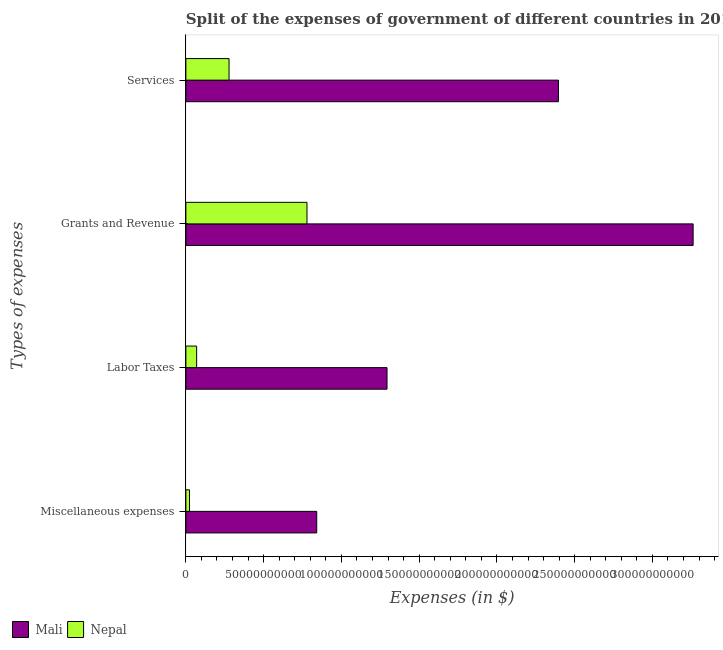How many different coloured bars are there?
Keep it short and to the point. 2. Are the number of bars per tick equal to the number of legend labels?
Offer a terse response. Yes. How many bars are there on the 1st tick from the bottom?
Your answer should be compact. 2. What is the label of the 4th group of bars from the top?
Offer a terse response. Miscellaneous expenses. What is the amount spent on grants and revenue in Nepal?
Your response must be concise. 7.79e+1. Across all countries, what is the maximum amount spent on grants and revenue?
Your answer should be compact. 3.26e+11. Across all countries, what is the minimum amount spent on miscellaneous expenses?
Provide a short and direct response. 2.33e+09. In which country was the amount spent on miscellaneous expenses maximum?
Keep it short and to the point. Mali. In which country was the amount spent on labor taxes minimum?
Keep it short and to the point. Nepal. What is the total amount spent on labor taxes in the graph?
Keep it short and to the point. 1.36e+11. What is the difference between the amount spent on grants and revenue in Nepal and that in Mali?
Offer a terse response. -2.48e+11. What is the difference between the amount spent on grants and revenue in Mali and the amount spent on services in Nepal?
Provide a short and direct response. 2.98e+11. What is the average amount spent on labor taxes per country?
Your answer should be very brief. 6.81e+1. What is the difference between the amount spent on grants and revenue and amount spent on miscellaneous expenses in Nepal?
Keep it short and to the point. 7.55e+1. In how many countries, is the amount spent on labor taxes greater than 150000000000 $?
Make the answer very short. 0. What is the ratio of the amount spent on services in Nepal to that in Mali?
Make the answer very short. 0.12. Is the amount spent on labor taxes in Mali less than that in Nepal?
Your response must be concise. No. Is the difference between the amount spent on grants and revenue in Nepal and Mali greater than the difference between the amount spent on services in Nepal and Mali?
Keep it short and to the point. No. What is the difference between the highest and the second highest amount spent on grants and revenue?
Make the answer very short. 2.48e+11. What is the difference between the highest and the lowest amount spent on services?
Your answer should be very brief. 2.12e+11. In how many countries, is the amount spent on grants and revenue greater than the average amount spent on grants and revenue taken over all countries?
Provide a short and direct response. 1. Is the sum of the amount spent on labor taxes in Nepal and Mali greater than the maximum amount spent on miscellaneous expenses across all countries?
Keep it short and to the point. Yes. Is it the case that in every country, the sum of the amount spent on labor taxes and amount spent on miscellaneous expenses is greater than the sum of amount spent on grants and revenue and amount spent on services?
Keep it short and to the point. No. What does the 2nd bar from the top in Grants and Revenue represents?
Provide a short and direct response. Mali. What does the 1st bar from the bottom in Miscellaneous expenses represents?
Keep it short and to the point. Mali. Is it the case that in every country, the sum of the amount spent on miscellaneous expenses and amount spent on labor taxes is greater than the amount spent on grants and revenue?
Offer a very short reply. No. How many countries are there in the graph?
Ensure brevity in your answer.  2. What is the difference between two consecutive major ticks on the X-axis?
Keep it short and to the point. 5.00e+1. Are the values on the major ticks of X-axis written in scientific E-notation?
Provide a succinct answer. No. Does the graph contain any zero values?
Ensure brevity in your answer.  No. Where does the legend appear in the graph?
Give a very brief answer. Bottom left. What is the title of the graph?
Your answer should be very brief. Split of the expenses of government of different countries in 2013. Does "Chile" appear as one of the legend labels in the graph?
Offer a very short reply. No. What is the label or title of the X-axis?
Your answer should be compact. Expenses (in $). What is the label or title of the Y-axis?
Provide a succinct answer. Types of expenses. What is the Expenses (in $) in Mali in Miscellaneous expenses?
Make the answer very short. 8.41e+1. What is the Expenses (in $) in Nepal in Miscellaneous expenses?
Provide a succinct answer. 2.33e+09. What is the Expenses (in $) of Mali in Labor Taxes?
Keep it short and to the point. 1.29e+11. What is the Expenses (in $) of Nepal in Labor Taxes?
Offer a very short reply. 6.92e+09. What is the Expenses (in $) of Mali in Grants and Revenue?
Make the answer very short. 3.26e+11. What is the Expenses (in $) of Nepal in Grants and Revenue?
Your response must be concise. 7.79e+1. What is the Expenses (in $) of Mali in Services?
Give a very brief answer. 2.40e+11. What is the Expenses (in $) of Nepal in Services?
Make the answer very short. 2.78e+1. Across all Types of expenses, what is the maximum Expenses (in $) in Mali?
Give a very brief answer. 3.26e+11. Across all Types of expenses, what is the maximum Expenses (in $) of Nepal?
Offer a terse response. 7.79e+1. Across all Types of expenses, what is the minimum Expenses (in $) in Mali?
Provide a succinct answer. 8.41e+1. Across all Types of expenses, what is the minimum Expenses (in $) in Nepal?
Your answer should be compact. 2.33e+09. What is the total Expenses (in $) of Mali in the graph?
Provide a succinct answer. 7.79e+11. What is the total Expenses (in $) in Nepal in the graph?
Give a very brief answer. 1.15e+11. What is the difference between the Expenses (in $) of Mali in Miscellaneous expenses and that in Labor Taxes?
Make the answer very short. -4.52e+1. What is the difference between the Expenses (in $) in Nepal in Miscellaneous expenses and that in Labor Taxes?
Provide a short and direct response. -4.59e+09. What is the difference between the Expenses (in $) of Mali in Miscellaneous expenses and that in Grants and Revenue?
Your response must be concise. -2.42e+11. What is the difference between the Expenses (in $) of Nepal in Miscellaneous expenses and that in Grants and Revenue?
Provide a short and direct response. -7.55e+1. What is the difference between the Expenses (in $) of Mali in Miscellaneous expenses and that in Services?
Provide a succinct answer. -1.55e+11. What is the difference between the Expenses (in $) in Nepal in Miscellaneous expenses and that in Services?
Offer a terse response. -2.54e+1. What is the difference between the Expenses (in $) in Mali in Labor Taxes and that in Grants and Revenue?
Offer a terse response. -1.97e+11. What is the difference between the Expenses (in $) in Nepal in Labor Taxes and that in Grants and Revenue?
Ensure brevity in your answer.  -7.10e+1. What is the difference between the Expenses (in $) of Mali in Labor Taxes and that in Services?
Give a very brief answer. -1.10e+11. What is the difference between the Expenses (in $) in Nepal in Labor Taxes and that in Services?
Provide a short and direct response. -2.08e+1. What is the difference between the Expenses (in $) of Mali in Grants and Revenue and that in Services?
Your response must be concise. 8.66e+1. What is the difference between the Expenses (in $) in Nepal in Grants and Revenue and that in Services?
Offer a terse response. 5.01e+1. What is the difference between the Expenses (in $) of Mali in Miscellaneous expenses and the Expenses (in $) of Nepal in Labor Taxes?
Offer a terse response. 7.72e+1. What is the difference between the Expenses (in $) in Mali in Miscellaneous expenses and the Expenses (in $) in Nepal in Grants and Revenue?
Give a very brief answer. 6.26e+09. What is the difference between the Expenses (in $) in Mali in Miscellaneous expenses and the Expenses (in $) in Nepal in Services?
Give a very brief answer. 5.64e+1. What is the difference between the Expenses (in $) in Mali in Labor Taxes and the Expenses (in $) in Nepal in Grants and Revenue?
Your answer should be very brief. 5.15e+1. What is the difference between the Expenses (in $) in Mali in Labor Taxes and the Expenses (in $) in Nepal in Services?
Ensure brevity in your answer.  1.02e+11. What is the difference between the Expenses (in $) of Mali in Grants and Revenue and the Expenses (in $) of Nepal in Services?
Your response must be concise. 2.98e+11. What is the average Expenses (in $) in Mali per Types of expenses?
Give a very brief answer. 1.95e+11. What is the average Expenses (in $) in Nepal per Types of expenses?
Give a very brief answer. 2.87e+1. What is the difference between the Expenses (in $) in Mali and Expenses (in $) in Nepal in Miscellaneous expenses?
Ensure brevity in your answer.  8.18e+1. What is the difference between the Expenses (in $) of Mali and Expenses (in $) of Nepal in Labor Taxes?
Offer a terse response. 1.22e+11. What is the difference between the Expenses (in $) of Mali and Expenses (in $) of Nepal in Grants and Revenue?
Offer a terse response. 2.48e+11. What is the difference between the Expenses (in $) of Mali and Expenses (in $) of Nepal in Services?
Ensure brevity in your answer.  2.12e+11. What is the ratio of the Expenses (in $) of Mali in Miscellaneous expenses to that in Labor Taxes?
Your answer should be compact. 0.65. What is the ratio of the Expenses (in $) of Nepal in Miscellaneous expenses to that in Labor Taxes?
Make the answer very short. 0.34. What is the ratio of the Expenses (in $) in Mali in Miscellaneous expenses to that in Grants and Revenue?
Give a very brief answer. 0.26. What is the ratio of the Expenses (in $) of Nepal in Miscellaneous expenses to that in Grants and Revenue?
Keep it short and to the point. 0.03. What is the ratio of the Expenses (in $) of Mali in Miscellaneous expenses to that in Services?
Offer a terse response. 0.35. What is the ratio of the Expenses (in $) of Nepal in Miscellaneous expenses to that in Services?
Provide a short and direct response. 0.08. What is the ratio of the Expenses (in $) in Mali in Labor Taxes to that in Grants and Revenue?
Offer a very short reply. 0.4. What is the ratio of the Expenses (in $) in Nepal in Labor Taxes to that in Grants and Revenue?
Offer a terse response. 0.09. What is the ratio of the Expenses (in $) in Mali in Labor Taxes to that in Services?
Ensure brevity in your answer.  0.54. What is the ratio of the Expenses (in $) in Nepal in Labor Taxes to that in Services?
Your answer should be very brief. 0.25. What is the ratio of the Expenses (in $) of Mali in Grants and Revenue to that in Services?
Provide a short and direct response. 1.36. What is the ratio of the Expenses (in $) in Nepal in Grants and Revenue to that in Services?
Make the answer very short. 2.81. What is the difference between the highest and the second highest Expenses (in $) of Mali?
Provide a succinct answer. 8.66e+1. What is the difference between the highest and the second highest Expenses (in $) of Nepal?
Offer a terse response. 5.01e+1. What is the difference between the highest and the lowest Expenses (in $) of Mali?
Your answer should be very brief. 2.42e+11. What is the difference between the highest and the lowest Expenses (in $) in Nepal?
Your answer should be very brief. 7.55e+1. 